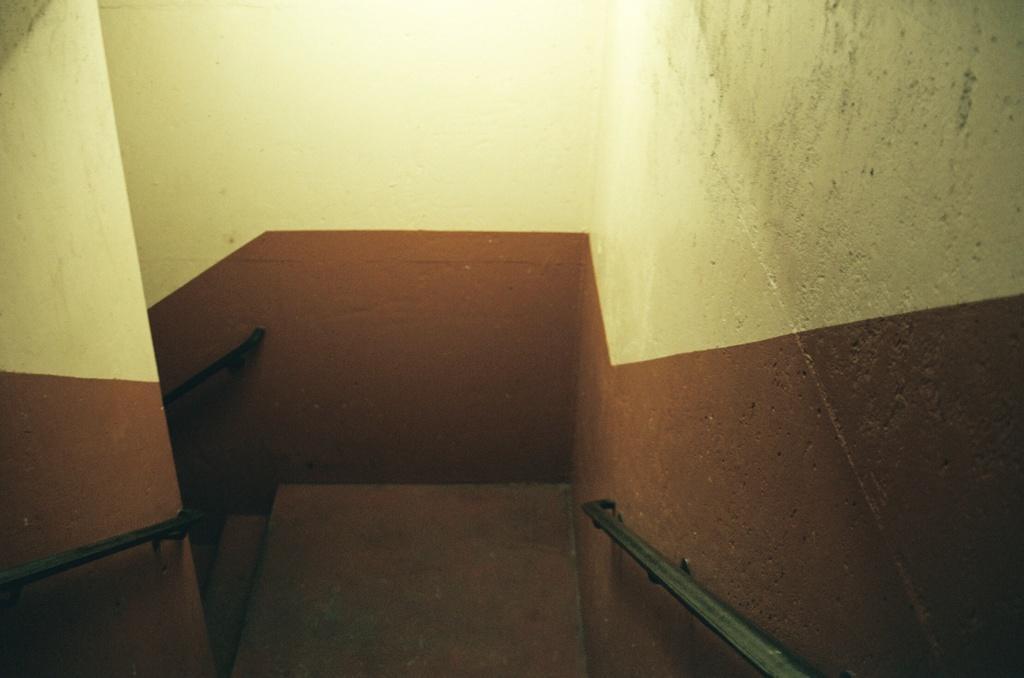In one or two sentences, can you explain what this image depicts? In this image there are stairs. On the left and right side of the image there are metal rods attached to the wall. 